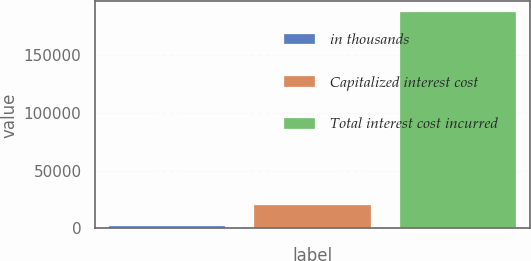<chart> <loc_0><loc_0><loc_500><loc_500><bar_chart><fcel>in thousands<fcel>Capitalized interest cost<fcel>Total interest cost incurred<nl><fcel>2008<fcel>20512.8<fcel>187056<nl></chart> 